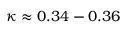<formula> <loc_0><loc_0><loc_500><loc_500>\kappa \approx 0 . 3 4 - 0 . 3 6</formula> 